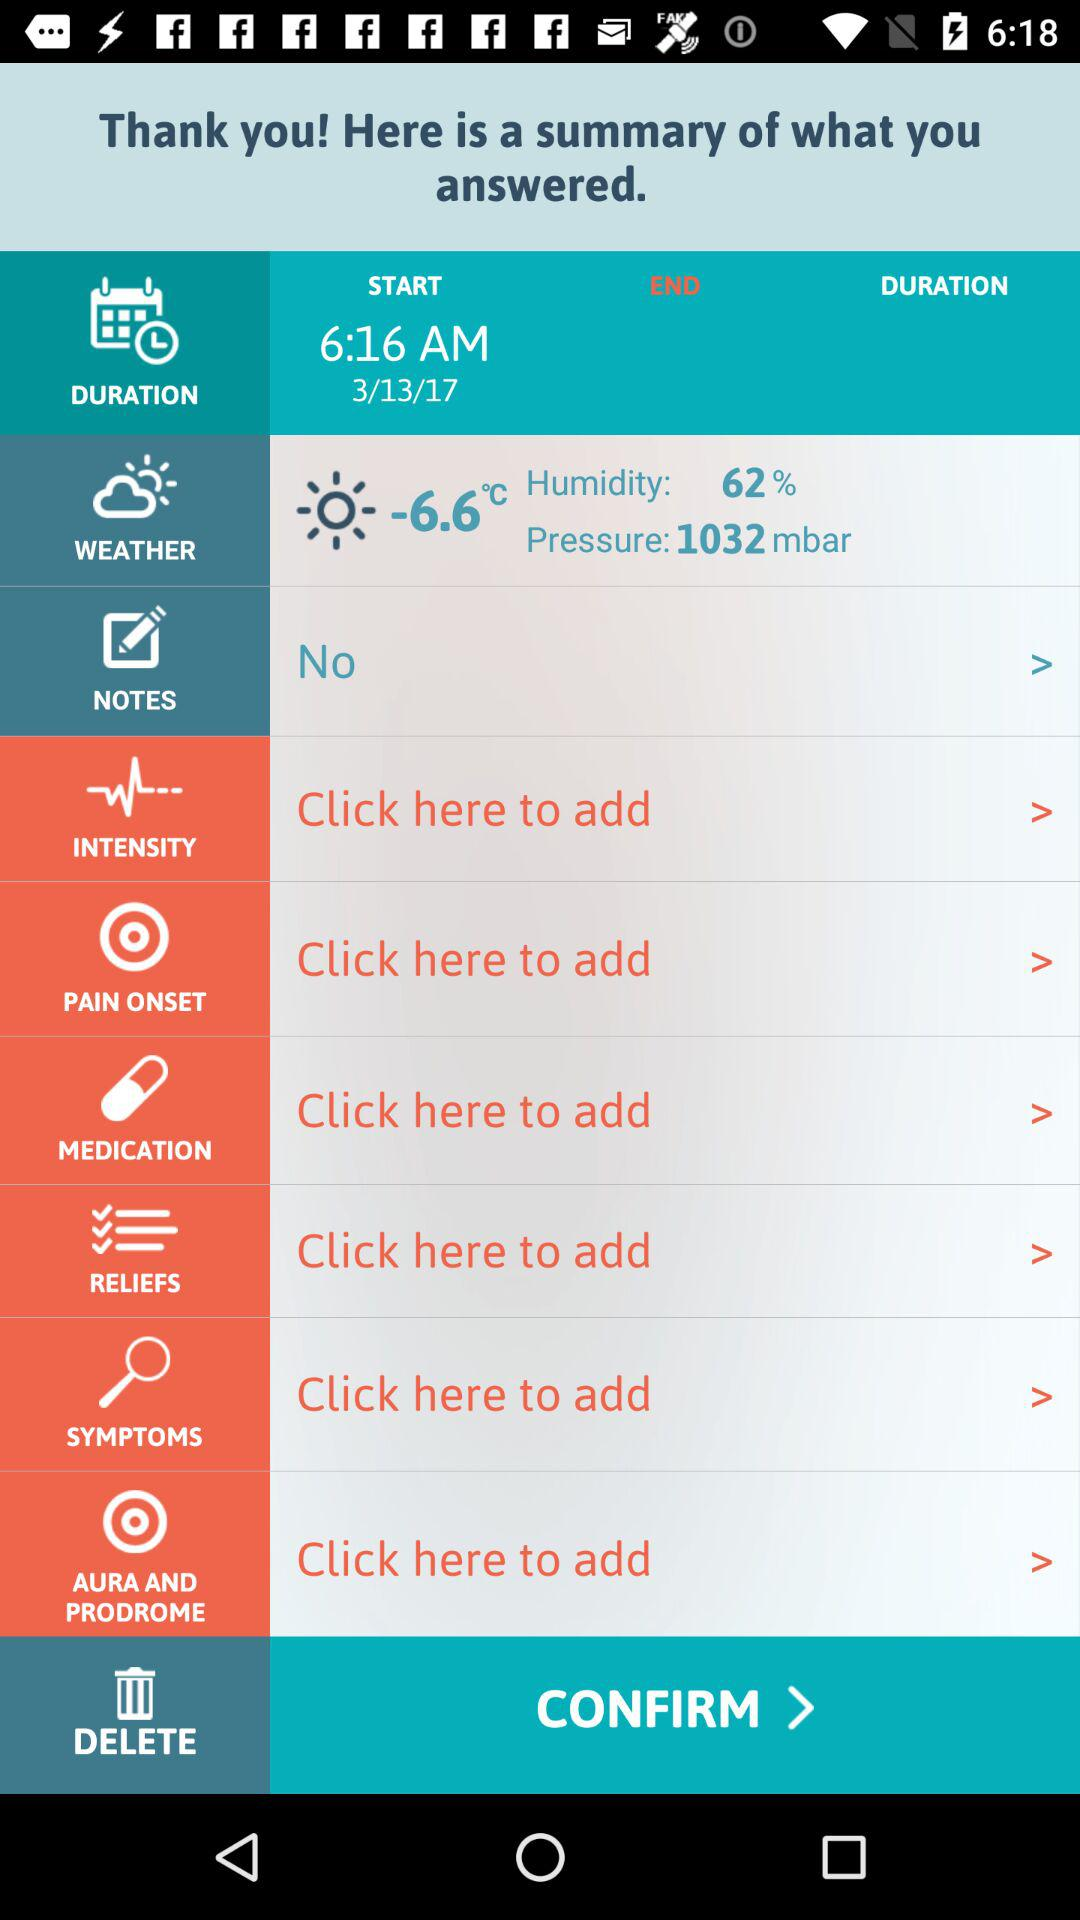What is the humidity percentage? The humidity percentage is 62. 